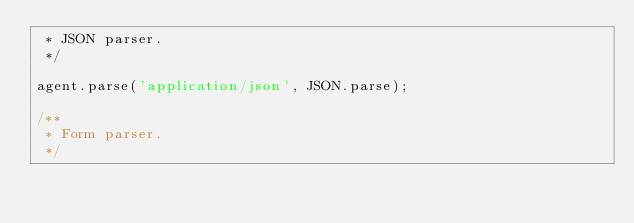<code> <loc_0><loc_0><loc_500><loc_500><_JavaScript_> * JSON parser.
 */

agent.parse('application/json', JSON.parse);

/**
 * Form parser.
 */
</code> 